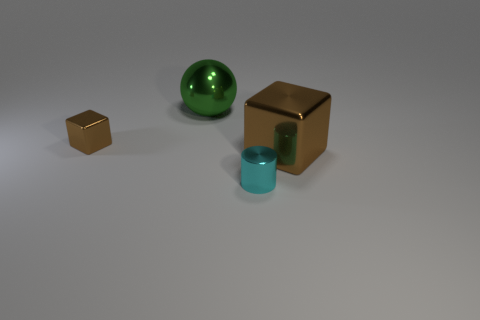There is a metal cube left of the shiny ball; are there any brown cubes in front of it?
Ensure brevity in your answer.  Yes. There is another shiny thing that is the same shape as the tiny brown thing; what is its color?
Provide a short and direct response. Brown. Does the shiny thing that is on the left side of the ball have the same color as the big metal cube?
Provide a short and direct response. Yes. What number of objects are either big shiny things that are in front of the green object or big yellow blocks?
Offer a terse response. 1. What is the small object in front of the brown metal thing that is in front of the brown metal cube left of the green thing made of?
Give a very brief answer. Metal. Are there more tiny brown shiny blocks that are in front of the tiny brown metallic cube than green metal balls that are right of the small metallic cylinder?
Keep it short and to the point. No. How many blocks are either big gray matte objects or metal things?
Make the answer very short. 2. What number of tiny brown metal cubes are on the left side of the brown thing that is to the left of the big shiny object behind the big cube?
Your answer should be compact. 0. There is a thing that is the same color as the large metal cube; what is its material?
Ensure brevity in your answer.  Metal. Are there more big gray metal cubes than big brown metallic blocks?
Give a very brief answer. No. 